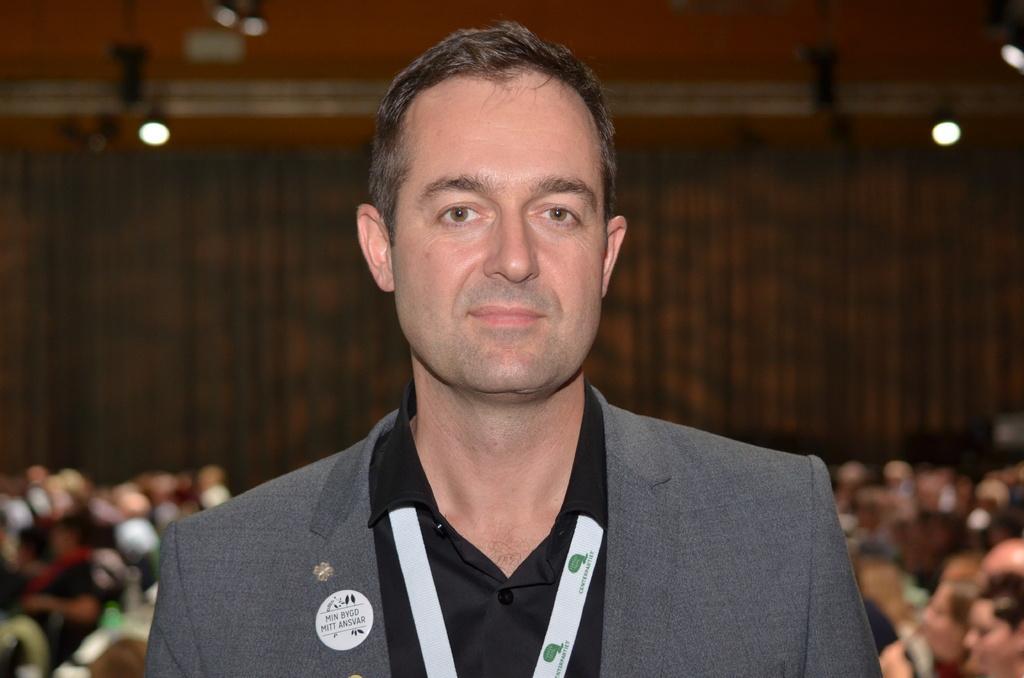Please provide a concise description of this image. In this image we can see a person. On the backside we can see a group of people sitting. We can also see a wall and some lights. 